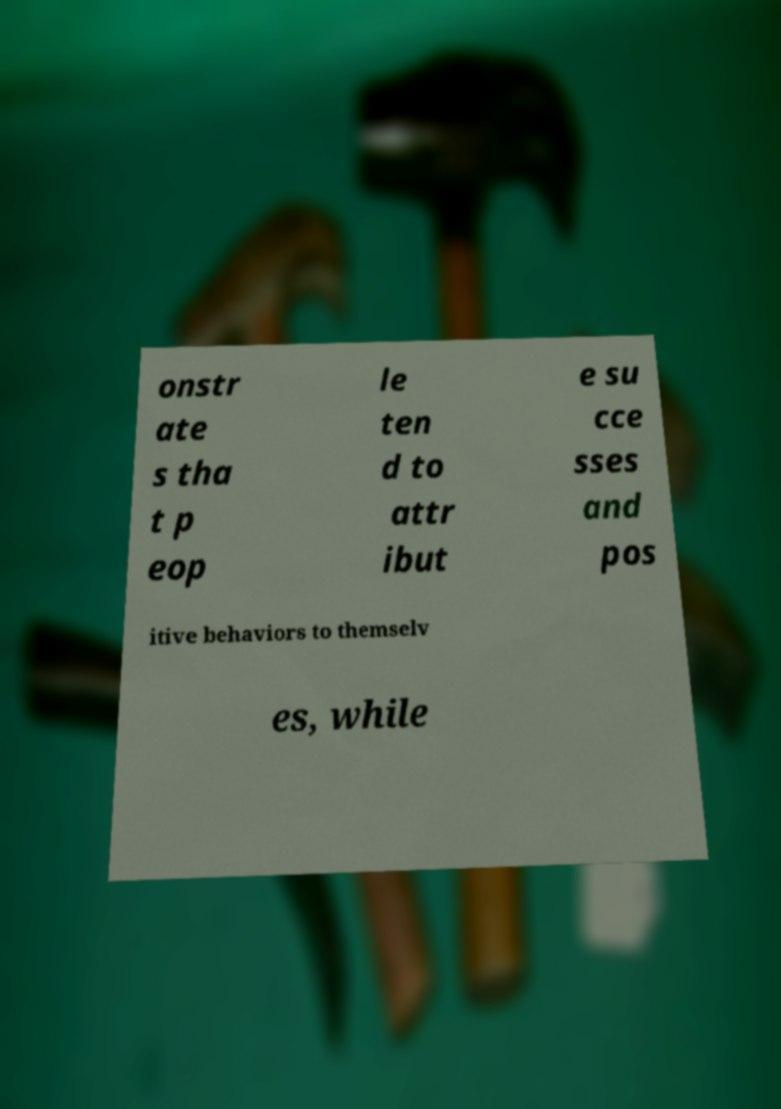Can you read and provide the text displayed in the image?This photo seems to have some interesting text. Can you extract and type it out for me? onstr ate s tha t p eop le ten d to attr ibut e su cce sses and pos itive behaviors to themselv es, while 